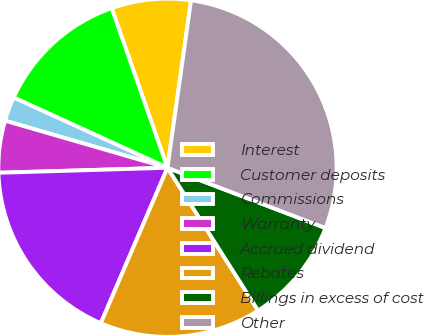<chart> <loc_0><loc_0><loc_500><loc_500><pie_chart><fcel>Interest<fcel>Customer deposits<fcel>Commissions<fcel>Warranty<fcel>Accrued dividend<fcel>Rebates<fcel>Billings in excess of cost<fcel>Other<nl><fcel>7.58%<fcel>12.83%<fcel>2.33%<fcel>4.96%<fcel>18.08%<fcel>15.45%<fcel>10.2%<fcel>28.57%<nl></chart> 